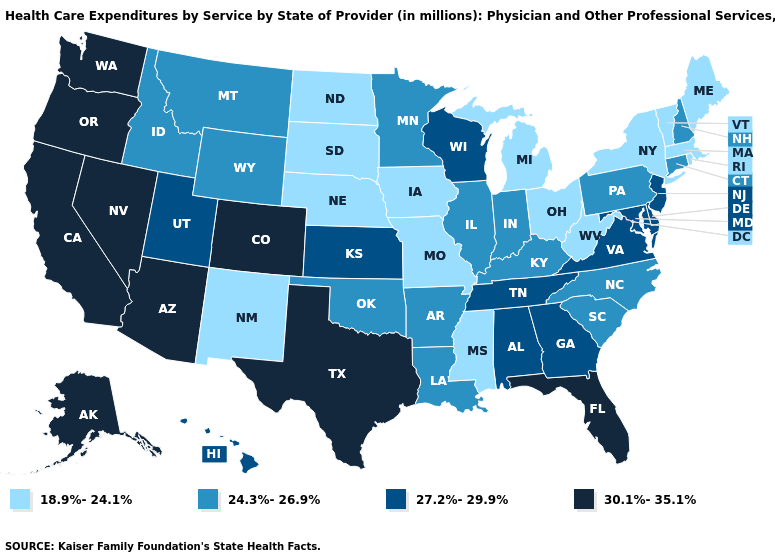Name the states that have a value in the range 24.3%-26.9%?
Answer briefly. Arkansas, Connecticut, Idaho, Illinois, Indiana, Kentucky, Louisiana, Minnesota, Montana, New Hampshire, North Carolina, Oklahoma, Pennsylvania, South Carolina, Wyoming. Name the states that have a value in the range 30.1%-35.1%?
Write a very short answer. Alaska, Arizona, California, Colorado, Florida, Nevada, Oregon, Texas, Washington. Does Idaho have a higher value than Ohio?
Be succinct. Yes. Name the states that have a value in the range 27.2%-29.9%?
Keep it brief. Alabama, Delaware, Georgia, Hawaii, Kansas, Maryland, New Jersey, Tennessee, Utah, Virginia, Wisconsin. Does North Dakota have the same value as Arkansas?
Keep it brief. No. Name the states that have a value in the range 18.9%-24.1%?
Concise answer only. Iowa, Maine, Massachusetts, Michigan, Mississippi, Missouri, Nebraska, New Mexico, New York, North Dakota, Ohio, Rhode Island, South Dakota, Vermont, West Virginia. What is the value of Iowa?
Answer briefly. 18.9%-24.1%. Name the states that have a value in the range 24.3%-26.9%?
Give a very brief answer. Arkansas, Connecticut, Idaho, Illinois, Indiana, Kentucky, Louisiana, Minnesota, Montana, New Hampshire, North Carolina, Oklahoma, Pennsylvania, South Carolina, Wyoming. Among the states that border South Dakota , which have the highest value?
Keep it brief. Minnesota, Montana, Wyoming. Among the states that border Tennessee , which have the lowest value?
Write a very short answer. Mississippi, Missouri. Does Texas have the lowest value in the South?
Give a very brief answer. No. Among the states that border Nebraska , which have the lowest value?
Be succinct. Iowa, Missouri, South Dakota. What is the lowest value in states that border Georgia?
Answer briefly. 24.3%-26.9%. Among the states that border Oregon , does Nevada have the lowest value?
Keep it brief. No. Name the states that have a value in the range 30.1%-35.1%?
Write a very short answer. Alaska, Arizona, California, Colorado, Florida, Nevada, Oregon, Texas, Washington. 